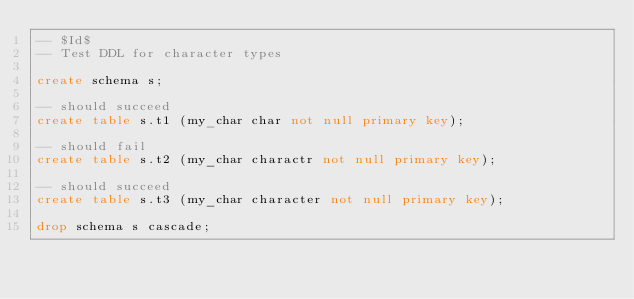Convert code to text. <code><loc_0><loc_0><loc_500><loc_500><_SQL_>-- $Id$
-- Test DDL for character types

create schema s;

-- should succeed
create table s.t1 (my_char char not null primary key);

-- should fail
create table s.t2 (my_char charactr not null primary key);

-- should succeed
create table s.t3 (my_char character not null primary key);

drop schema s cascade;

</code> 